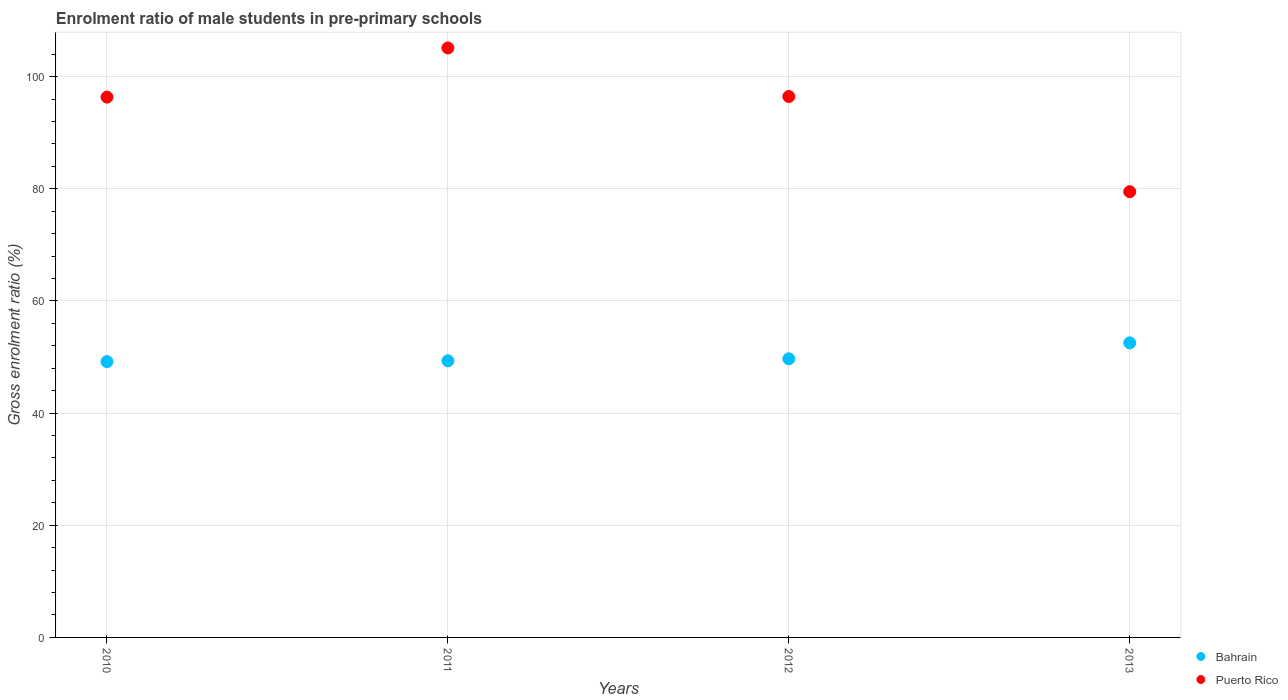Is the number of dotlines equal to the number of legend labels?
Your answer should be very brief. Yes. What is the enrolment ratio of male students in pre-primary schools in Puerto Rico in 2013?
Keep it short and to the point. 79.47. Across all years, what is the maximum enrolment ratio of male students in pre-primary schools in Bahrain?
Provide a succinct answer. 52.51. Across all years, what is the minimum enrolment ratio of male students in pre-primary schools in Bahrain?
Keep it short and to the point. 49.18. What is the total enrolment ratio of male students in pre-primary schools in Puerto Rico in the graph?
Provide a short and direct response. 377.36. What is the difference between the enrolment ratio of male students in pre-primary schools in Puerto Rico in 2011 and that in 2013?
Your answer should be very brief. 25.63. What is the difference between the enrolment ratio of male students in pre-primary schools in Bahrain in 2011 and the enrolment ratio of male students in pre-primary schools in Puerto Rico in 2010?
Make the answer very short. -47.02. What is the average enrolment ratio of male students in pre-primary schools in Bahrain per year?
Ensure brevity in your answer.  50.17. In the year 2013, what is the difference between the enrolment ratio of male students in pre-primary schools in Puerto Rico and enrolment ratio of male students in pre-primary schools in Bahrain?
Give a very brief answer. 26.96. What is the ratio of the enrolment ratio of male students in pre-primary schools in Bahrain in 2012 to that in 2013?
Your answer should be very brief. 0.95. What is the difference between the highest and the second highest enrolment ratio of male students in pre-primary schools in Bahrain?
Ensure brevity in your answer.  2.84. What is the difference between the highest and the lowest enrolment ratio of male students in pre-primary schools in Bahrain?
Make the answer very short. 3.33. In how many years, is the enrolment ratio of male students in pre-primary schools in Bahrain greater than the average enrolment ratio of male students in pre-primary schools in Bahrain taken over all years?
Give a very brief answer. 1. Is the enrolment ratio of male students in pre-primary schools in Bahrain strictly greater than the enrolment ratio of male students in pre-primary schools in Puerto Rico over the years?
Give a very brief answer. No. How many dotlines are there?
Your response must be concise. 2. How many years are there in the graph?
Your response must be concise. 4. Does the graph contain any zero values?
Provide a succinct answer. No. Where does the legend appear in the graph?
Offer a terse response. Bottom right. How many legend labels are there?
Your response must be concise. 2. What is the title of the graph?
Your answer should be very brief. Enrolment ratio of male students in pre-primary schools. Does "Panama" appear as one of the legend labels in the graph?
Offer a very short reply. No. What is the label or title of the X-axis?
Offer a very short reply. Years. What is the label or title of the Y-axis?
Your answer should be very brief. Gross enrolment ratio (%). What is the Gross enrolment ratio (%) of Bahrain in 2010?
Ensure brevity in your answer.  49.18. What is the Gross enrolment ratio (%) in Puerto Rico in 2010?
Your response must be concise. 96.34. What is the Gross enrolment ratio (%) in Bahrain in 2011?
Offer a very short reply. 49.32. What is the Gross enrolment ratio (%) in Puerto Rico in 2011?
Your response must be concise. 105.11. What is the Gross enrolment ratio (%) in Bahrain in 2012?
Your answer should be compact. 49.68. What is the Gross enrolment ratio (%) of Puerto Rico in 2012?
Offer a very short reply. 96.45. What is the Gross enrolment ratio (%) of Bahrain in 2013?
Give a very brief answer. 52.51. What is the Gross enrolment ratio (%) of Puerto Rico in 2013?
Provide a short and direct response. 79.47. Across all years, what is the maximum Gross enrolment ratio (%) in Bahrain?
Provide a succinct answer. 52.51. Across all years, what is the maximum Gross enrolment ratio (%) of Puerto Rico?
Offer a very short reply. 105.11. Across all years, what is the minimum Gross enrolment ratio (%) of Bahrain?
Offer a very short reply. 49.18. Across all years, what is the minimum Gross enrolment ratio (%) of Puerto Rico?
Your response must be concise. 79.47. What is the total Gross enrolment ratio (%) of Bahrain in the graph?
Your response must be concise. 200.69. What is the total Gross enrolment ratio (%) in Puerto Rico in the graph?
Offer a very short reply. 377.36. What is the difference between the Gross enrolment ratio (%) in Bahrain in 2010 and that in 2011?
Keep it short and to the point. -0.14. What is the difference between the Gross enrolment ratio (%) of Puerto Rico in 2010 and that in 2011?
Your answer should be compact. -8.77. What is the difference between the Gross enrolment ratio (%) in Bahrain in 2010 and that in 2012?
Offer a terse response. -0.49. What is the difference between the Gross enrolment ratio (%) in Puerto Rico in 2010 and that in 2012?
Make the answer very short. -0.11. What is the difference between the Gross enrolment ratio (%) in Bahrain in 2010 and that in 2013?
Your answer should be compact. -3.33. What is the difference between the Gross enrolment ratio (%) of Puerto Rico in 2010 and that in 2013?
Provide a short and direct response. 16.87. What is the difference between the Gross enrolment ratio (%) of Bahrain in 2011 and that in 2012?
Your answer should be very brief. -0.35. What is the difference between the Gross enrolment ratio (%) in Puerto Rico in 2011 and that in 2012?
Keep it short and to the point. 8.66. What is the difference between the Gross enrolment ratio (%) of Bahrain in 2011 and that in 2013?
Provide a succinct answer. -3.19. What is the difference between the Gross enrolment ratio (%) in Puerto Rico in 2011 and that in 2013?
Provide a short and direct response. 25.63. What is the difference between the Gross enrolment ratio (%) of Bahrain in 2012 and that in 2013?
Your response must be concise. -2.84. What is the difference between the Gross enrolment ratio (%) of Puerto Rico in 2012 and that in 2013?
Ensure brevity in your answer.  16.98. What is the difference between the Gross enrolment ratio (%) of Bahrain in 2010 and the Gross enrolment ratio (%) of Puerto Rico in 2011?
Provide a succinct answer. -55.93. What is the difference between the Gross enrolment ratio (%) of Bahrain in 2010 and the Gross enrolment ratio (%) of Puerto Rico in 2012?
Provide a short and direct response. -47.27. What is the difference between the Gross enrolment ratio (%) of Bahrain in 2010 and the Gross enrolment ratio (%) of Puerto Rico in 2013?
Make the answer very short. -30.29. What is the difference between the Gross enrolment ratio (%) of Bahrain in 2011 and the Gross enrolment ratio (%) of Puerto Rico in 2012?
Provide a short and direct response. -47.13. What is the difference between the Gross enrolment ratio (%) in Bahrain in 2011 and the Gross enrolment ratio (%) in Puerto Rico in 2013?
Your answer should be very brief. -30.15. What is the difference between the Gross enrolment ratio (%) of Bahrain in 2012 and the Gross enrolment ratio (%) of Puerto Rico in 2013?
Your answer should be very brief. -29.8. What is the average Gross enrolment ratio (%) in Bahrain per year?
Your response must be concise. 50.17. What is the average Gross enrolment ratio (%) of Puerto Rico per year?
Provide a short and direct response. 94.34. In the year 2010, what is the difference between the Gross enrolment ratio (%) of Bahrain and Gross enrolment ratio (%) of Puerto Rico?
Keep it short and to the point. -47.16. In the year 2011, what is the difference between the Gross enrolment ratio (%) in Bahrain and Gross enrolment ratio (%) in Puerto Rico?
Offer a very short reply. -55.79. In the year 2012, what is the difference between the Gross enrolment ratio (%) in Bahrain and Gross enrolment ratio (%) in Puerto Rico?
Offer a very short reply. -46.77. In the year 2013, what is the difference between the Gross enrolment ratio (%) of Bahrain and Gross enrolment ratio (%) of Puerto Rico?
Provide a short and direct response. -26.96. What is the ratio of the Gross enrolment ratio (%) of Bahrain in 2010 to that in 2011?
Provide a short and direct response. 1. What is the ratio of the Gross enrolment ratio (%) in Puerto Rico in 2010 to that in 2011?
Your answer should be very brief. 0.92. What is the ratio of the Gross enrolment ratio (%) in Bahrain in 2010 to that in 2012?
Keep it short and to the point. 0.99. What is the ratio of the Gross enrolment ratio (%) of Puerto Rico in 2010 to that in 2012?
Keep it short and to the point. 1. What is the ratio of the Gross enrolment ratio (%) in Bahrain in 2010 to that in 2013?
Your answer should be compact. 0.94. What is the ratio of the Gross enrolment ratio (%) in Puerto Rico in 2010 to that in 2013?
Give a very brief answer. 1.21. What is the ratio of the Gross enrolment ratio (%) of Puerto Rico in 2011 to that in 2012?
Ensure brevity in your answer.  1.09. What is the ratio of the Gross enrolment ratio (%) of Bahrain in 2011 to that in 2013?
Your answer should be compact. 0.94. What is the ratio of the Gross enrolment ratio (%) in Puerto Rico in 2011 to that in 2013?
Your answer should be very brief. 1.32. What is the ratio of the Gross enrolment ratio (%) in Bahrain in 2012 to that in 2013?
Your response must be concise. 0.95. What is the ratio of the Gross enrolment ratio (%) of Puerto Rico in 2012 to that in 2013?
Your answer should be compact. 1.21. What is the difference between the highest and the second highest Gross enrolment ratio (%) of Bahrain?
Keep it short and to the point. 2.84. What is the difference between the highest and the second highest Gross enrolment ratio (%) of Puerto Rico?
Offer a very short reply. 8.66. What is the difference between the highest and the lowest Gross enrolment ratio (%) of Bahrain?
Your answer should be very brief. 3.33. What is the difference between the highest and the lowest Gross enrolment ratio (%) in Puerto Rico?
Offer a very short reply. 25.63. 